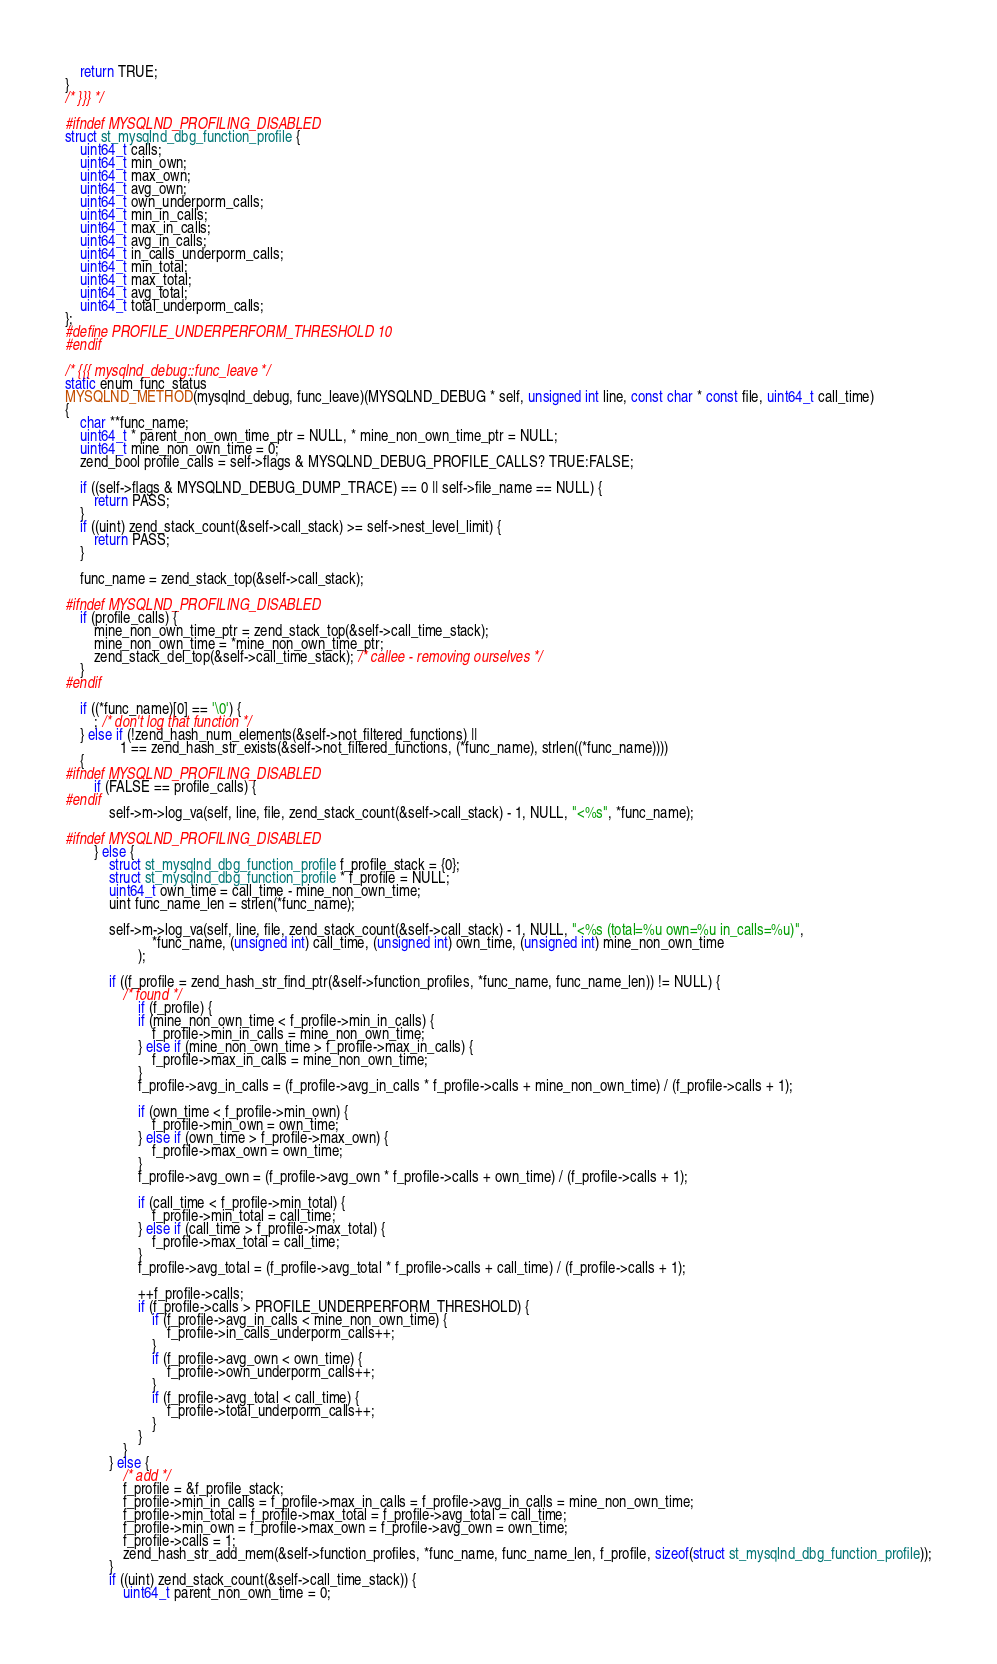<code> <loc_0><loc_0><loc_500><loc_500><_C_>	return TRUE;
}
/* }}} */

#ifndef MYSQLND_PROFILING_DISABLED
struct st_mysqlnd_dbg_function_profile {
	uint64_t calls;
	uint64_t min_own;
	uint64_t max_own;
	uint64_t avg_own;
	uint64_t own_underporm_calls;
	uint64_t min_in_calls;
	uint64_t max_in_calls;
	uint64_t avg_in_calls;
	uint64_t in_calls_underporm_calls;
	uint64_t min_total;
	uint64_t max_total;
	uint64_t avg_total;
	uint64_t total_underporm_calls;
};
#define PROFILE_UNDERPERFORM_THRESHOLD 10
#endif

/* {{{ mysqlnd_debug::func_leave */
static enum_func_status
MYSQLND_METHOD(mysqlnd_debug, func_leave)(MYSQLND_DEBUG * self, unsigned int line, const char * const file, uint64_t call_time)
{
	char **func_name;
	uint64_t * parent_non_own_time_ptr = NULL, * mine_non_own_time_ptr = NULL;
	uint64_t mine_non_own_time = 0;
	zend_bool profile_calls = self->flags & MYSQLND_DEBUG_PROFILE_CALLS? TRUE:FALSE;

	if ((self->flags & MYSQLND_DEBUG_DUMP_TRACE) == 0 || self->file_name == NULL) {
		return PASS;
	}
	if ((uint) zend_stack_count(&self->call_stack) >= self->nest_level_limit) {
		return PASS;
	}

	func_name = zend_stack_top(&self->call_stack);

#ifndef MYSQLND_PROFILING_DISABLED
	if (profile_calls) {
		mine_non_own_time_ptr = zend_stack_top(&self->call_time_stack);
		mine_non_own_time = *mine_non_own_time_ptr;
		zend_stack_del_top(&self->call_time_stack); /* callee - removing ourselves */
	}
#endif

	if ((*func_name)[0] == '\0') {
		; /* don't log that function */
	} else if (!zend_hash_num_elements(&self->not_filtered_functions) ||
			   1 == zend_hash_str_exists(&self->not_filtered_functions, (*func_name), strlen((*func_name))))
	{
#ifndef MYSQLND_PROFILING_DISABLED
		if (FALSE == profile_calls) {
#endif
			self->m->log_va(self, line, file, zend_stack_count(&self->call_stack) - 1, NULL, "<%s", *func_name);

#ifndef MYSQLND_PROFILING_DISABLED
		} else {
			struct st_mysqlnd_dbg_function_profile f_profile_stack = {0};
			struct st_mysqlnd_dbg_function_profile * f_profile = NULL;
			uint64_t own_time = call_time - mine_non_own_time;
			uint func_name_len = strlen(*func_name);

			self->m->log_va(self, line, file, zend_stack_count(&self->call_stack) - 1, NULL, "<%s (total=%u own=%u in_calls=%u)",
						*func_name, (unsigned int) call_time, (unsigned int) own_time, (unsigned int) mine_non_own_time
					);

			if ((f_profile = zend_hash_str_find_ptr(&self->function_profiles, *func_name, func_name_len)) != NULL) {
				/* found */
					if (f_profile) {
					if (mine_non_own_time < f_profile->min_in_calls) {
						f_profile->min_in_calls = mine_non_own_time;
					} else if (mine_non_own_time > f_profile->max_in_calls) {
						f_profile->max_in_calls = mine_non_own_time;
					}
					f_profile->avg_in_calls = (f_profile->avg_in_calls * f_profile->calls + mine_non_own_time) / (f_profile->calls + 1);

					if (own_time < f_profile->min_own) {
						f_profile->min_own = own_time;
					} else if (own_time > f_profile->max_own) {
						f_profile->max_own = own_time;
					}
					f_profile->avg_own = (f_profile->avg_own * f_profile->calls + own_time) / (f_profile->calls + 1);

					if (call_time < f_profile->min_total) {
						f_profile->min_total = call_time;
					} else if (call_time > f_profile->max_total) {
						f_profile->max_total = call_time;
					}
					f_profile->avg_total = (f_profile->avg_total * f_profile->calls + call_time) / (f_profile->calls + 1);

					++f_profile->calls;
					if (f_profile->calls > PROFILE_UNDERPERFORM_THRESHOLD) {
						if (f_profile->avg_in_calls < mine_non_own_time) {
							f_profile->in_calls_underporm_calls++;
						}
						if (f_profile->avg_own < own_time) {
							f_profile->own_underporm_calls++;
						}
						if (f_profile->avg_total < call_time) {
							f_profile->total_underporm_calls++;
						}
					}
				}
			} else {
				/* add */
				f_profile = &f_profile_stack;
				f_profile->min_in_calls = f_profile->max_in_calls = f_profile->avg_in_calls = mine_non_own_time;
				f_profile->min_total = f_profile->max_total = f_profile->avg_total = call_time;
				f_profile->min_own = f_profile->max_own = f_profile->avg_own = own_time;
				f_profile->calls = 1;
				zend_hash_str_add_mem(&self->function_profiles, *func_name, func_name_len, f_profile, sizeof(struct st_mysqlnd_dbg_function_profile));
			}
			if ((uint) zend_stack_count(&self->call_time_stack)) {
				uint64_t parent_non_own_time = 0;
</code> 